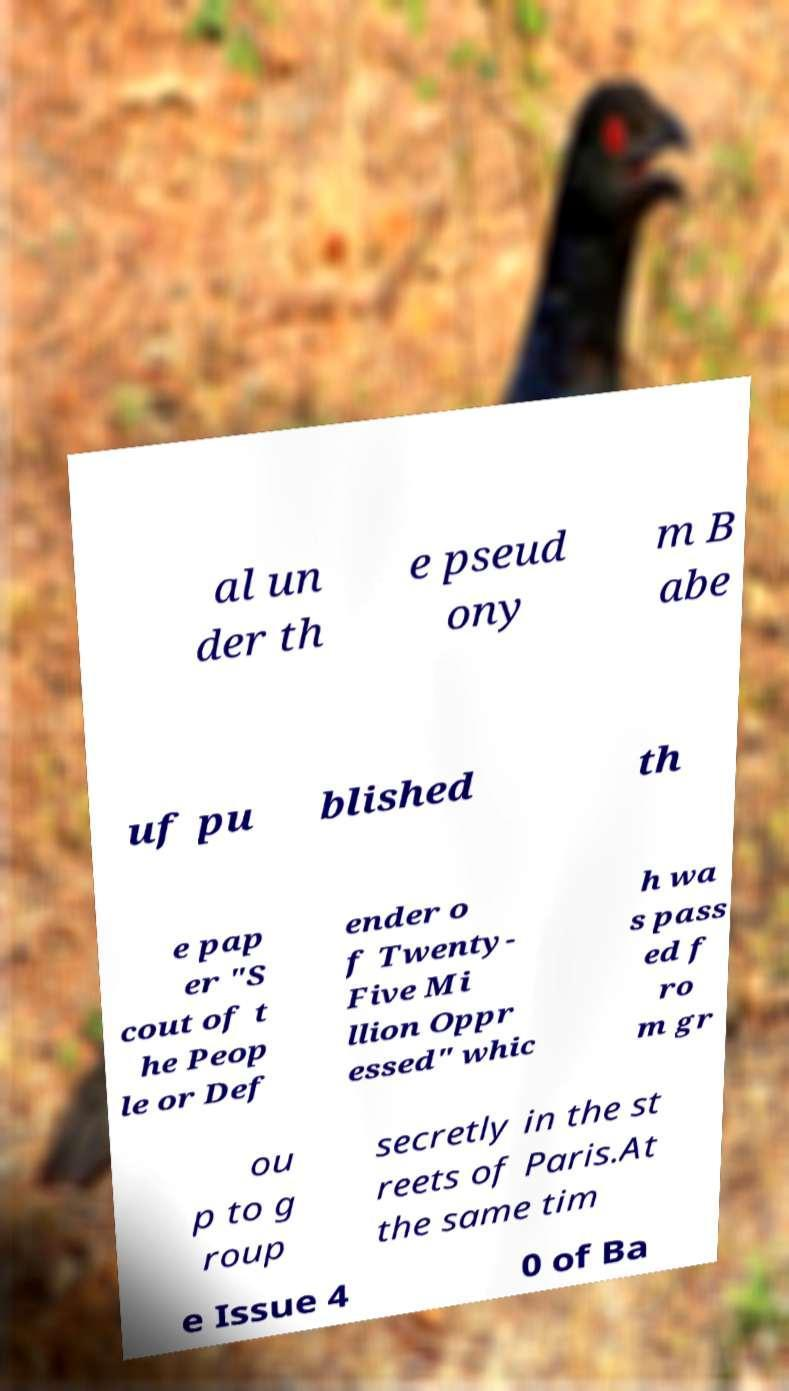Please read and relay the text visible in this image. What does it say? al un der th e pseud ony m B abe uf pu blished th e pap er "S cout of t he Peop le or Def ender o f Twenty- Five Mi llion Oppr essed" whic h wa s pass ed f ro m gr ou p to g roup secretly in the st reets of Paris.At the same tim e Issue 4 0 of Ba 